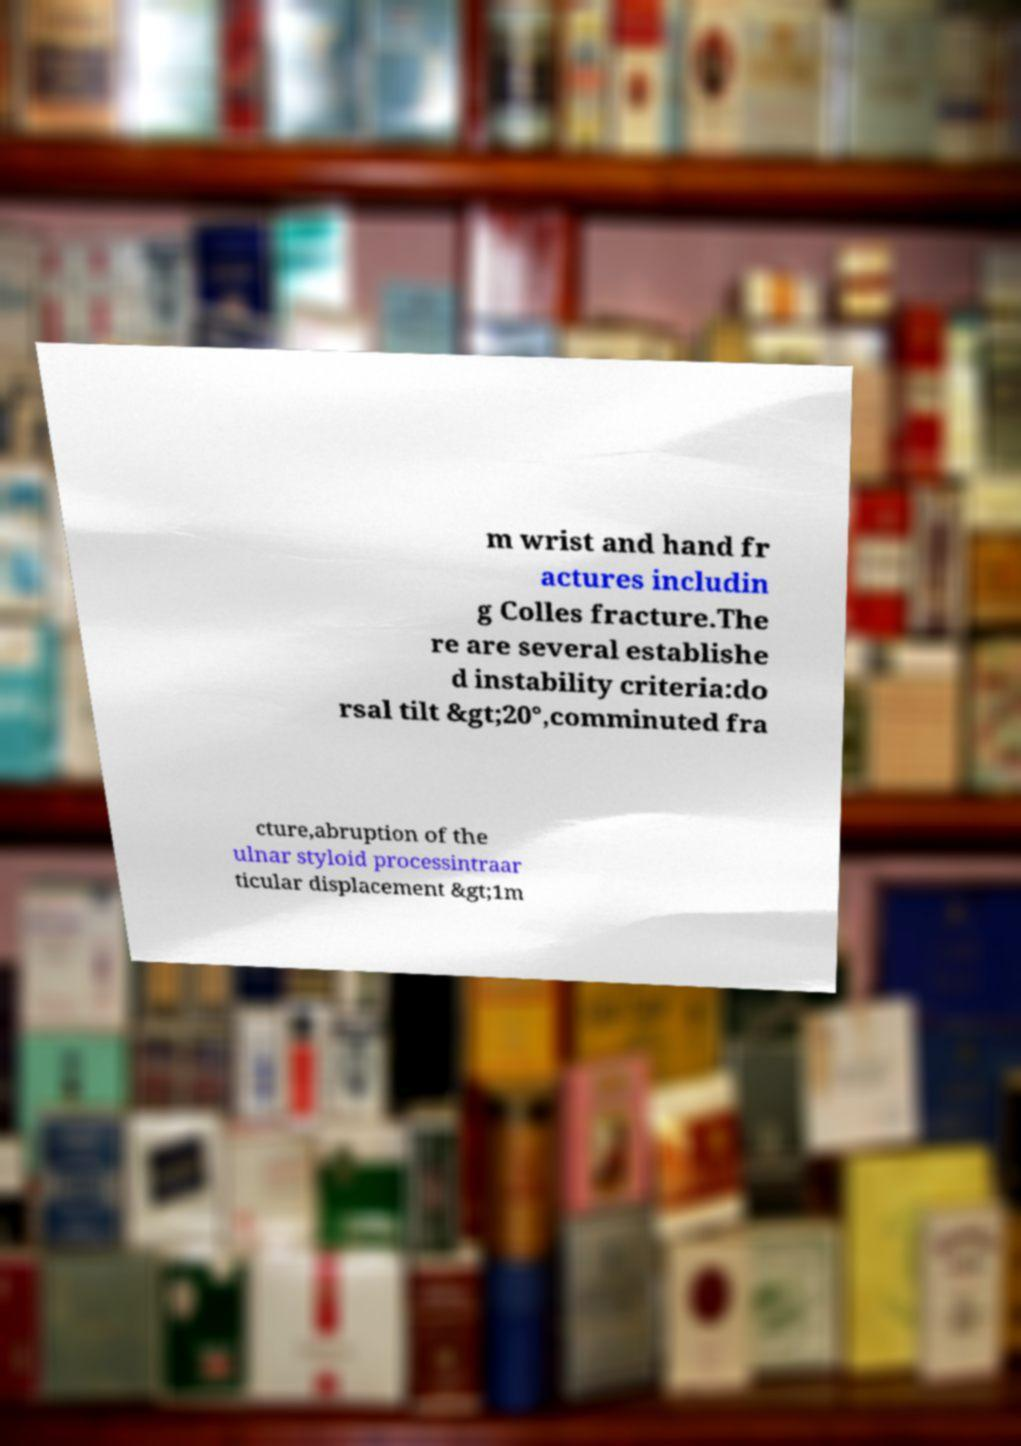There's text embedded in this image that I need extracted. Can you transcribe it verbatim? m wrist and hand fr actures includin g Colles fracture.The re are several establishe d instability criteria:do rsal tilt &gt;20°,comminuted fra cture,abruption of the ulnar styloid processintraar ticular displacement &gt;1m 